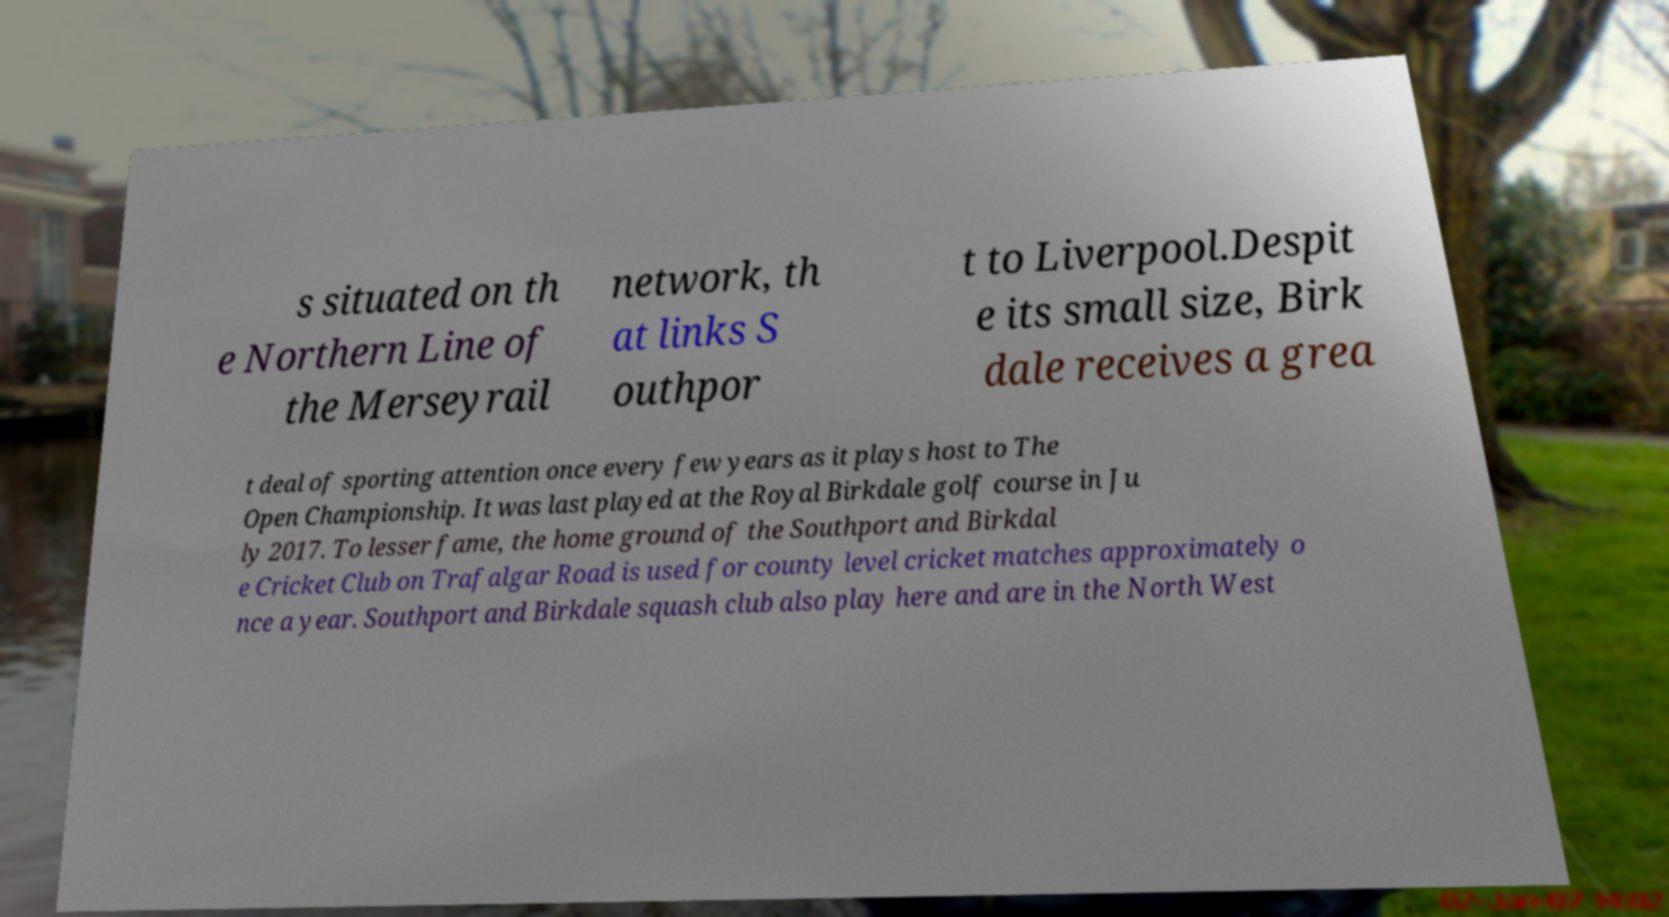Could you extract and type out the text from this image? s situated on th e Northern Line of the Merseyrail network, th at links S outhpor t to Liverpool.Despit e its small size, Birk dale receives a grea t deal of sporting attention once every few years as it plays host to The Open Championship. It was last played at the Royal Birkdale golf course in Ju ly 2017. To lesser fame, the home ground of the Southport and Birkdal e Cricket Club on Trafalgar Road is used for county level cricket matches approximately o nce a year. Southport and Birkdale squash club also play here and are in the North West 